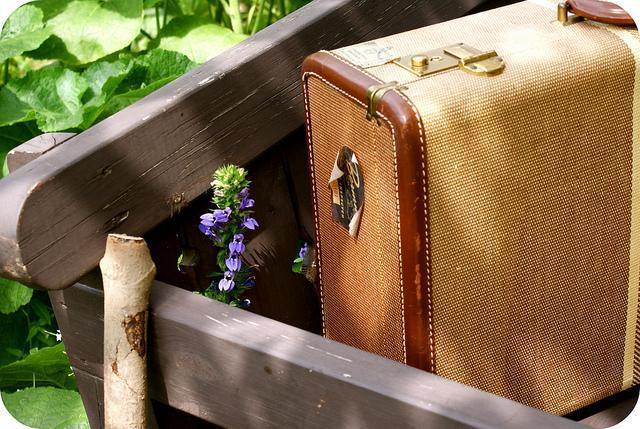How many people running with a kite on the sand?
Give a very brief answer. 0. 